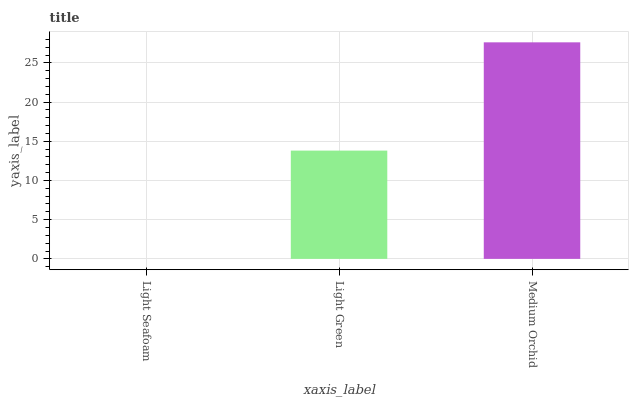Is Light Seafoam the minimum?
Answer yes or no. Yes. Is Medium Orchid the maximum?
Answer yes or no. Yes. Is Light Green the minimum?
Answer yes or no. No. Is Light Green the maximum?
Answer yes or no. No. Is Light Green greater than Light Seafoam?
Answer yes or no. Yes. Is Light Seafoam less than Light Green?
Answer yes or no. Yes. Is Light Seafoam greater than Light Green?
Answer yes or no. No. Is Light Green less than Light Seafoam?
Answer yes or no. No. Is Light Green the high median?
Answer yes or no. Yes. Is Light Green the low median?
Answer yes or no. Yes. Is Medium Orchid the high median?
Answer yes or no. No. Is Light Seafoam the low median?
Answer yes or no. No. 